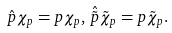Convert formula to latex. <formula><loc_0><loc_0><loc_500><loc_500>\hat { p } \chi _ { p } = p \chi _ { p } , \, \hat { \tilde { p } } \tilde { \chi } _ { p } = p \tilde { \chi } _ { p } .</formula> 